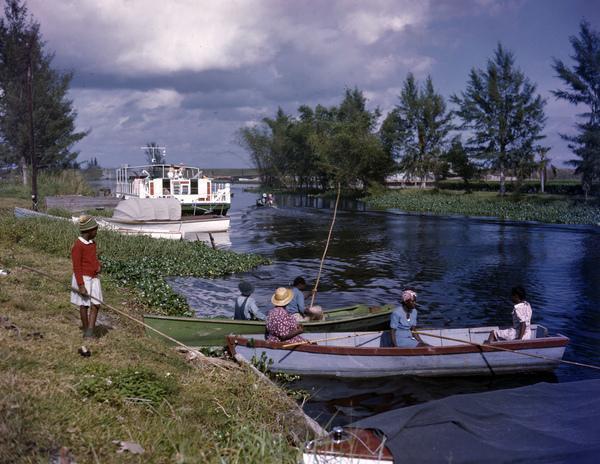How many boats are there?
Give a very brief answer. 5. 